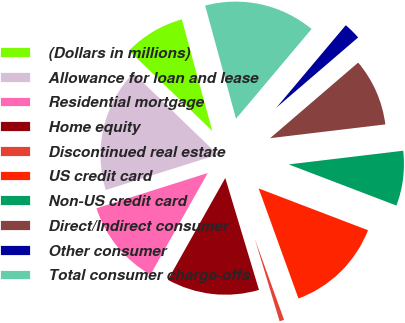Convert chart. <chart><loc_0><loc_0><loc_500><loc_500><pie_chart><fcel>(Dollars in millions)<fcel>Allowance for loan and lease<fcel>Residential mortgage<fcel>Home equity<fcel>Discontinued real estate<fcel>US credit card<fcel>Non-US credit card<fcel>Direct/Indirect consumer<fcel>Other consumer<fcel>Total consumer charge-offs<nl><fcel>8.55%<fcel>17.09%<fcel>11.96%<fcel>12.82%<fcel>0.87%<fcel>13.67%<fcel>7.7%<fcel>9.4%<fcel>2.57%<fcel>15.38%<nl></chart> 